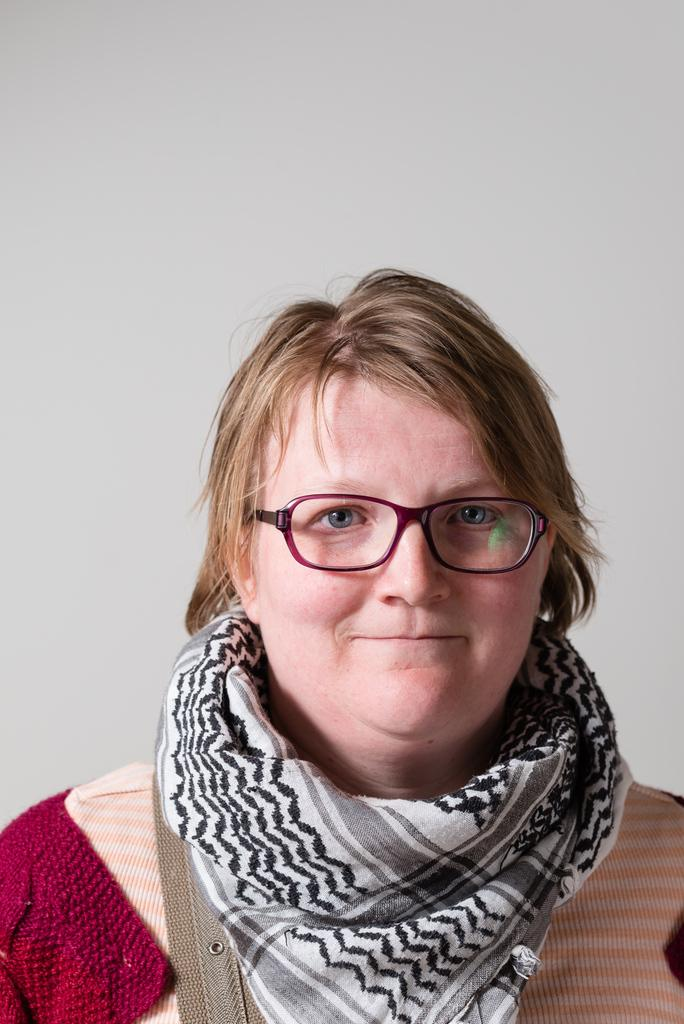Who is present in the image? There is a woman in the image. What is the woman wearing around her neck? The woman is wearing a scarf. What accessory is the woman wearing on her face? The woman is wearing spectacles. How is the woman's facial expression in the image? The woman has a smiley face. What can be seen in the background of the image? There is a white wall in the background of the image. What type of organization is depicted in the image? There is no organization depicted in the image; it features a woman wearing a scarf, spectacles, and a smiley face, with a white wall in the background. How many boats can be seen in the image? There are no boats present in the image. 